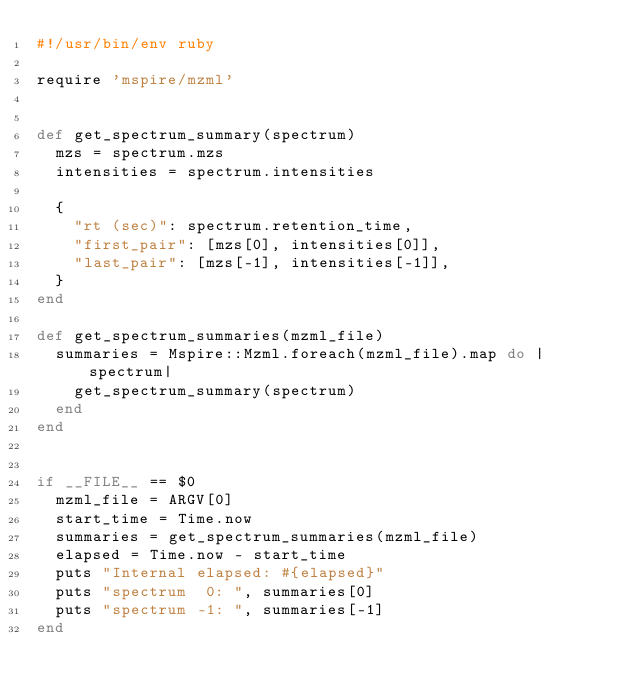<code> <loc_0><loc_0><loc_500><loc_500><_Ruby_>#!/usr/bin/env ruby

require 'mspire/mzml'


def get_spectrum_summary(spectrum)
  mzs = spectrum.mzs
  intensities = spectrum.intensities

  {
    "rt (sec)": spectrum.retention_time,
    "first_pair": [mzs[0], intensities[0]],
    "last_pair": [mzs[-1], intensities[-1]],
  }
end

def get_spectrum_summaries(mzml_file)
  summaries = Mspire::Mzml.foreach(mzml_file).map do |spectrum|
    get_spectrum_summary(spectrum)
  end
end


if __FILE__ == $0
  mzml_file = ARGV[0]
  start_time = Time.now
  summaries = get_spectrum_summaries(mzml_file)
  elapsed = Time.now - start_time
  puts "Internal elapsed: #{elapsed}"
  puts "spectrum  0: ", summaries[0]
  puts "spectrum -1: ", summaries[-1]
end
</code> 